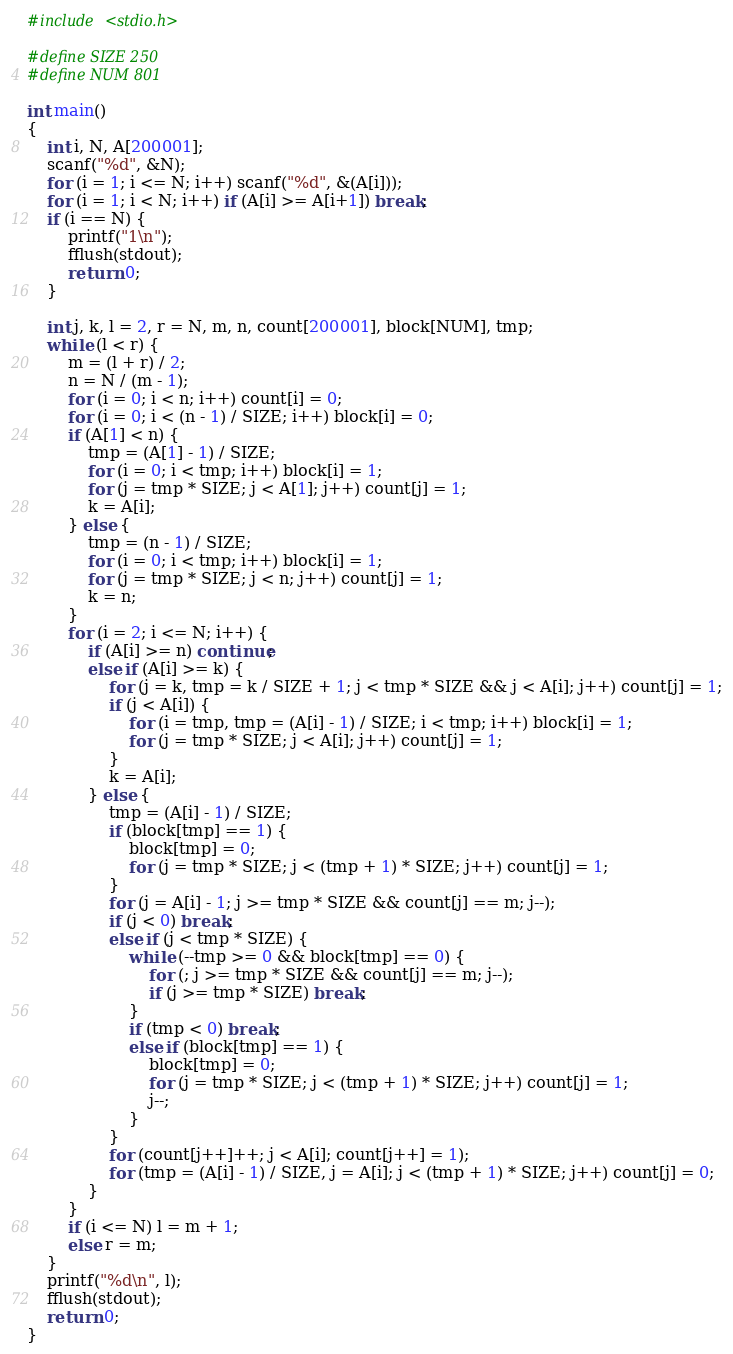Convert code to text. <code><loc_0><loc_0><loc_500><loc_500><_C_>#include <stdio.h>

#define SIZE 250
#define NUM 801

int main()
{
	int i, N, A[200001];
	scanf("%d", &N);
	for (i = 1; i <= N; i++) scanf("%d", &(A[i]));
	for (i = 1; i < N; i++) if (A[i] >= A[i+1]) break;
	if (i == N) {
		printf("1\n");
		fflush(stdout);
		return 0;
	}
	
	int j, k, l = 2, r = N, m, n, count[200001], block[NUM], tmp;
	while (l < r) {
		m = (l + r) / 2;
		n = N / (m - 1);
		for (i = 0; i < n; i++) count[i] = 0;
		for (i = 0; i < (n - 1) / SIZE; i++) block[i] = 0;
		if (A[1] < n) {
			tmp = (A[1] - 1) / SIZE;
			for (i = 0; i < tmp; i++) block[i] = 1;
			for (j = tmp * SIZE; j < A[1]; j++) count[j] = 1;
			k = A[i];
		} else {
			tmp = (n - 1) / SIZE;
			for (i = 0; i < tmp; i++) block[i] = 1;
			for (j = tmp * SIZE; j < n; j++) count[j] = 1;
			k = n;
		}
		for (i = 2; i <= N; i++) {
			if (A[i] >= n) continue;
			else if (A[i] >= k) {
				for (j = k, tmp = k / SIZE + 1; j < tmp * SIZE && j < A[i]; j++) count[j] = 1;
				if (j < A[i]) {
					for (i = tmp, tmp = (A[i] - 1) / SIZE; i < tmp; i++) block[i] = 1;
					for (j = tmp * SIZE; j < A[i]; j++) count[j] = 1;
				}
				k = A[i];
			} else {
				tmp = (A[i] - 1) / SIZE;
				if (block[tmp] == 1) {
					block[tmp] = 0;
					for (j = tmp * SIZE; j < (tmp + 1) * SIZE; j++) count[j] = 1;
				}
				for (j = A[i] - 1; j >= tmp * SIZE && count[j] == m; j--);
				if (j < 0) break;
				else if (j < tmp * SIZE) {
					while (--tmp >= 0 && block[tmp] == 0) {
						for (; j >= tmp * SIZE && count[j] == m; j--);
						if (j >= tmp * SIZE) break;
					}
					if (tmp < 0) break;
					else if (block[tmp] == 1) {
						block[tmp] = 0;
						for (j = tmp * SIZE; j < (tmp + 1) * SIZE; j++) count[j] = 1;
						j--;
					}
				}
				for (count[j++]++; j < A[i]; count[j++] = 1);
				for (tmp = (A[i] - 1) / SIZE, j = A[i]; j < (tmp + 1) * SIZE; j++) count[j] = 0;
			}
		}
		if (i <= N) l = m + 1;
		else r = m;
	}
	printf("%d\n", l);
	fflush(stdout);
	return 0;
}</code> 